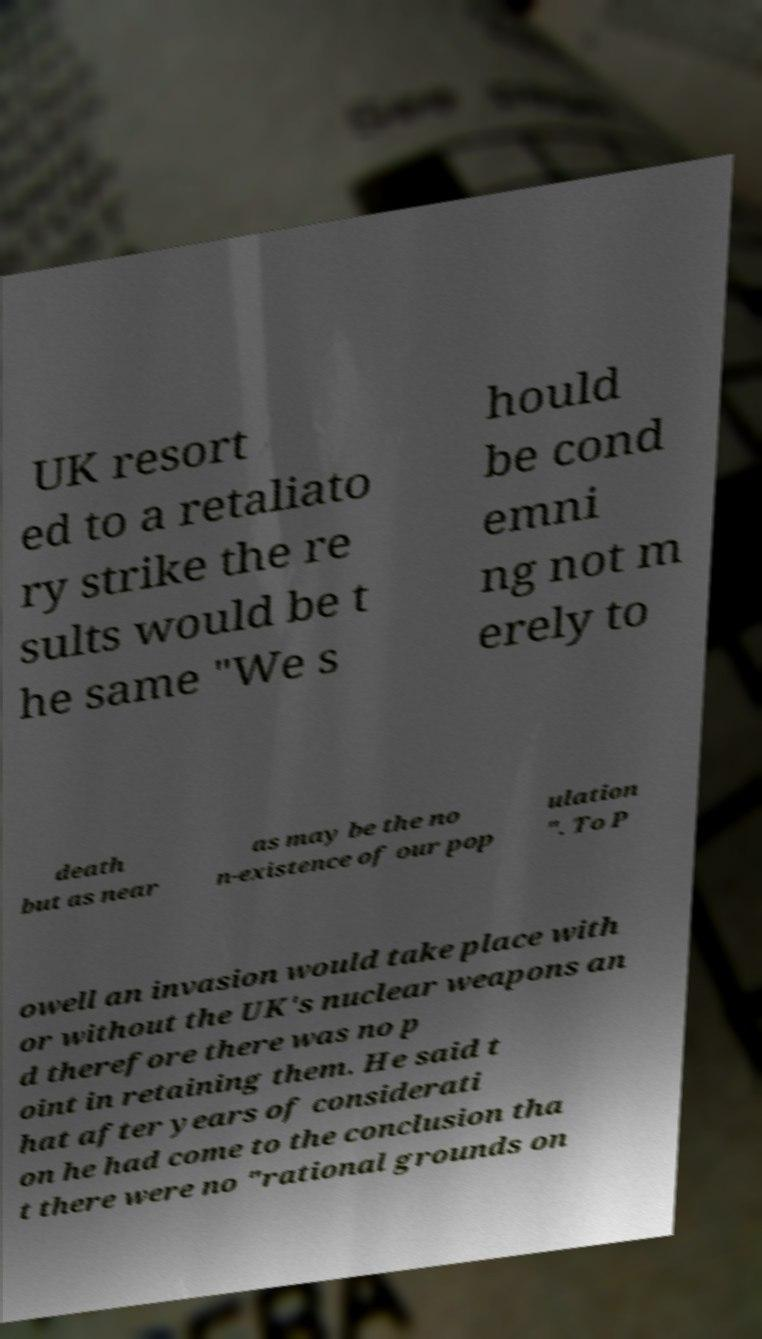Could you extract and type out the text from this image? UK resort ed to a retaliato ry strike the re sults would be t he same "We s hould be cond emni ng not m erely to death but as near as may be the no n-existence of our pop ulation ". To P owell an invasion would take place with or without the UK's nuclear weapons an d therefore there was no p oint in retaining them. He said t hat after years of considerati on he had come to the conclusion tha t there were no "rational grounds on 